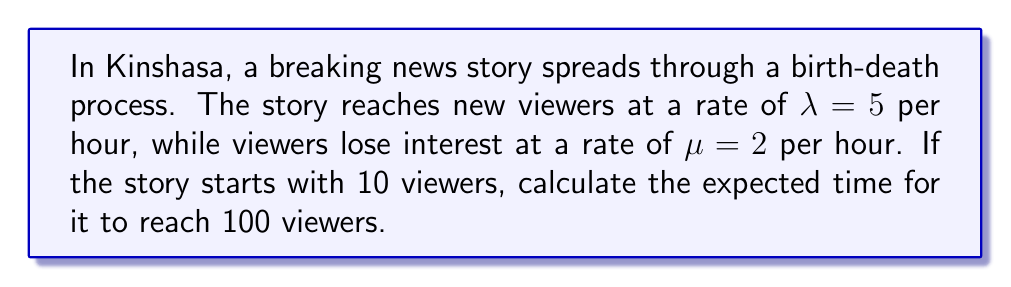Teach me how to tackle this problem. To solve this problem, we'll use the concept of birth-death processes and the expected time to reach a specific state.

Step 1: Identify the birth and death rates
Birth rate (new viewers): $\lambda = 5$ per hour
Death rate (loss of interest): $\mu = 2$ per hour

Step 2: Calculate the net growth rate
Net growth rate = $\lambda - \mu = 5 - 2 = 3$ per hour

Step 3: Use the formula for expected time to reach a specific state
For a birth-death process with birth rate $\lambda$ and death rate $\mu$, the expected time to go from state $i$ to state $j$ (where $j > i$) is given by:

$$E[T_{ij}] = \frac{1}{\lambda - \mu} \sum_{k=i}^{j-1} \frac{1}{k}$$

In our case:
$i = 10$ (initial number of viewers)
$j = 100$ (target number of viewers)
$\lambda - \mu = 3$

Step 4: Compute the sum
$$E[T_{10,100}] = \frac{1}{3} \sum_{k=10}^{99} \frac{1}{k}$$

This sum can be approximated using the difference of harmonic numbers:

$$\sum_{k=10}^{99} \frac{1}{k} \approx H_{99} - H_{9}$$

Where $H_n$ is the nth harmonic number.

Step 5: Calculate the result
Using a calculator or computer:

$$H_{99} - H_{9} \approx 5.1774 - 2.8289 = 2.3485$$

Therefore:

$$E[T_{10,100}] = \frac{1}{3} \cdot 2.3485 \approx 0.7828 \text{ hours}$$

Convert to minutes: $0.7828 \cdot 60 \approx 46.97$ minutes
Answer: Approximately 47 minutes 